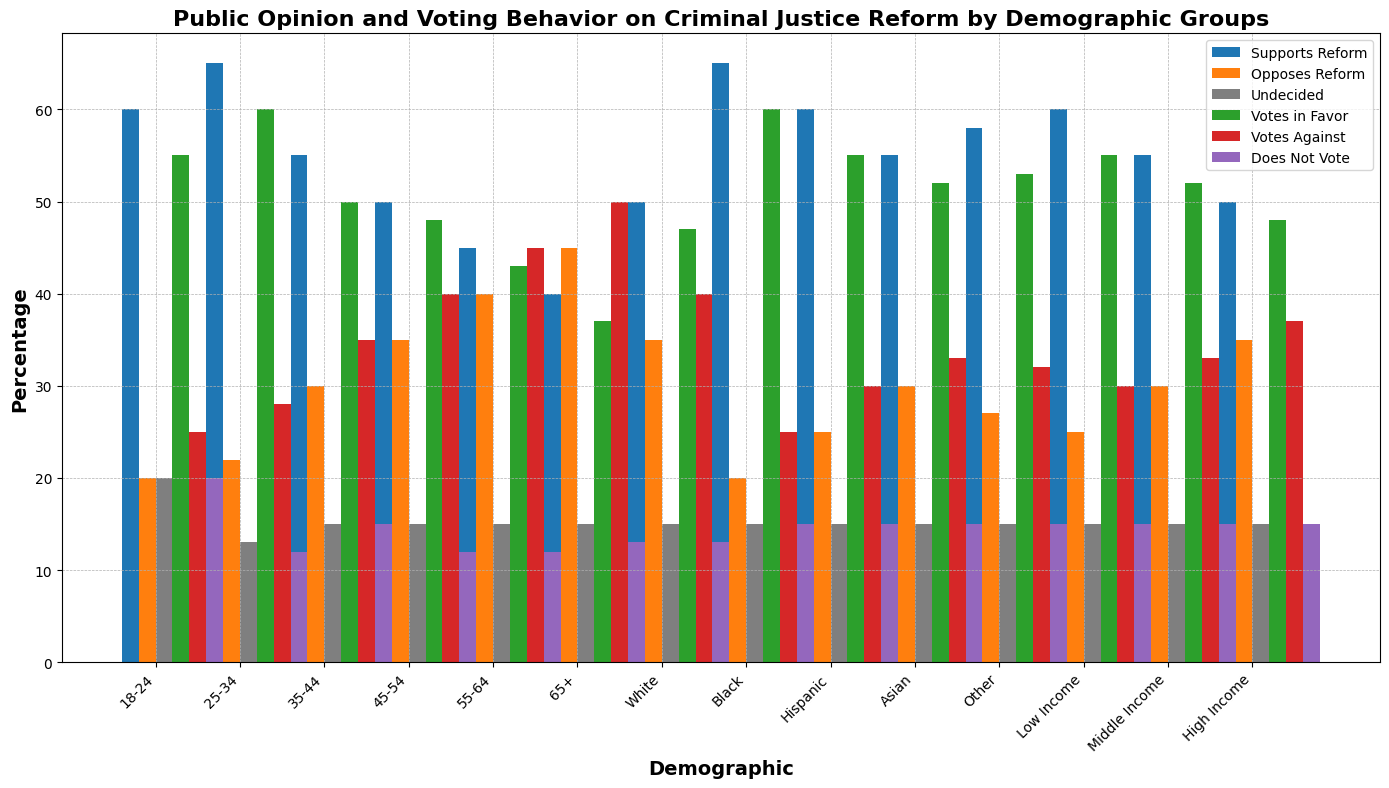Which demographic group has the highest percentage of people who support criminal justice reform? By looking at the heights of the blue bars for all demographic groups, the group with the highest blue bar is the 25-34 age group.
Answer: 25-34 age group Which income group has the lowest percentage of people who oppose criminal justice reform? Comparing the heights of the orange bars for Low Income, Middle Income, and High Income groups, the Low Income group has the shortest orange bar.
Answer: Low Income group How much more likely are people aged 18-24 to support criminal justice reform compared to those aged 65+? The blue bar for the 18-24 age group shows 60%, and the blue bar for the 65+ group shows 40%. Therefore, the difference is 60% - 40% = 20%.
Answer: 20% Which demographic group has the highest percentage of people who vote in favor of criminal justice reform? The green bars need to be compared for all demographic groups. The group with the highest green bar is the Black demographic with 60%.
Answer: Black demographic Are people aged 35-44 or those aged 55-64 more likely to be undecided about criminal justice reform? The gray bars for both age groups need to be compared. Both the 35-44 and 55-64 age groups have the same height gray bars at 15%.
Answer: Both are equally likely Which group among Asians or Hispanics has a higher percentage of votes against criminal justice reform? Comparing the red bars for Asians and Hispanics, the Asian group has a slightly higher red bar at 33% compared to 30% for Hispanics.
Answer: Asians What is the average percentage of people who do not vote across all age groups (18-24, 25-34, 35-44, 45-54, 55-64, 65+)? Sum the percentages of people who do not vote for each age group: 20% + 12% + 15% + 12% + 12% + 13% = 84%. Divide by the number of age groups, which is 6. 84% / 6 = 14%.
Answer: 14% Is the percentage of White people opposed to criminal justice reform higher or lower than Middle Income individuals who oppose it? Compare the orange bar for the White demographic at 35% with the orange bar for the Middle Income group at 30%. The percentage for White individuals is higher.
Answer: Higher Among the different age groups, which one has the closest levels of support and opposition for criminal justice reform? Compare the blue and orange bars for all age groups. The 55-64 age group has 45% support and 40% opposition, which are closest in values.
Answer: 55-64 age group Which demographic group has the highest percentage of people who are undecided about criminal justice reform? The gray bars for all demographic groups need to be examined. All groups show the same height for the gray bar at 15%.
Answer: All groups have the same percentage 